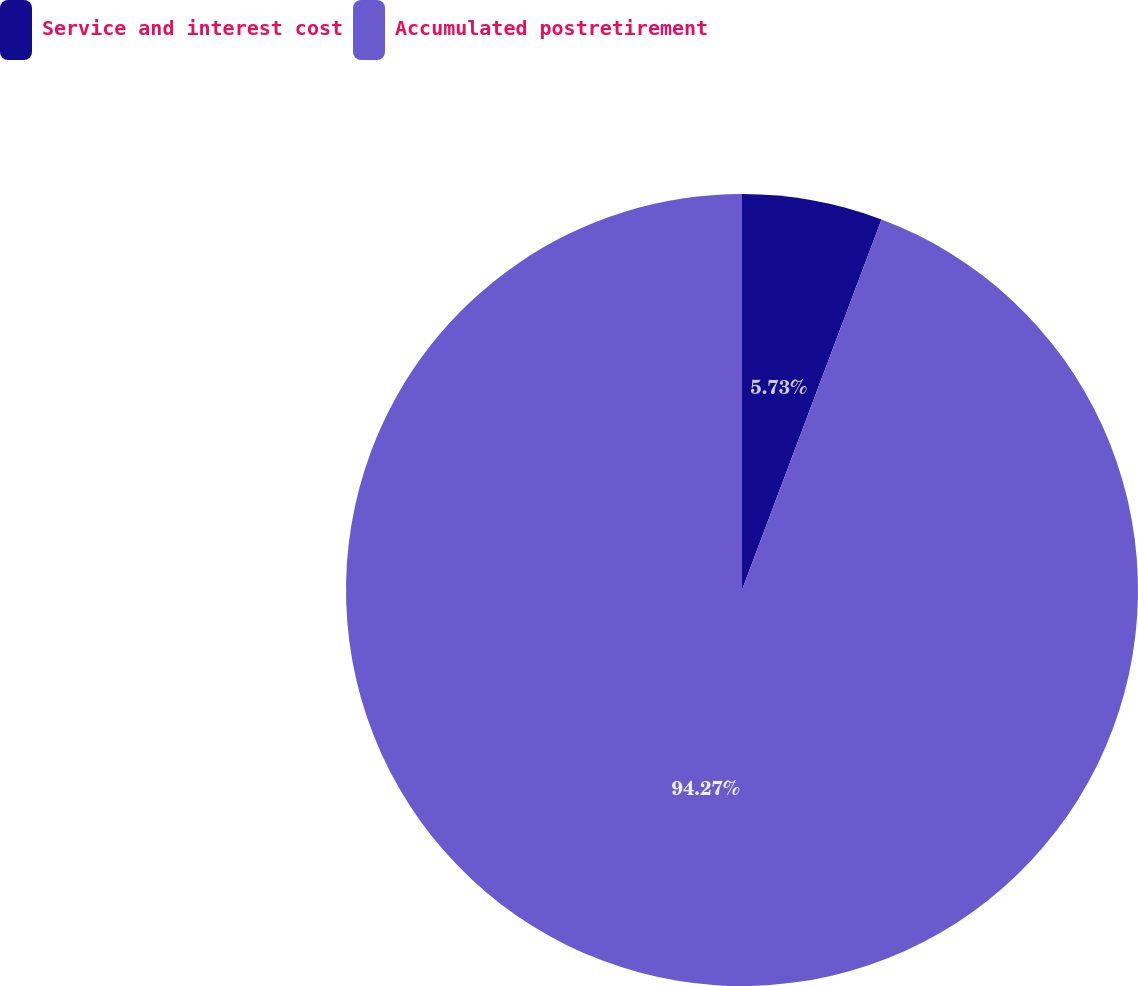<chart> <loc_0><loc_0><loc_500><loc_500><pie_chart><fcel>Service and interest cost<fcel>Accumulated postretirement<nl><fcel>5.73%<fcel>94.27%<nl></chart> 